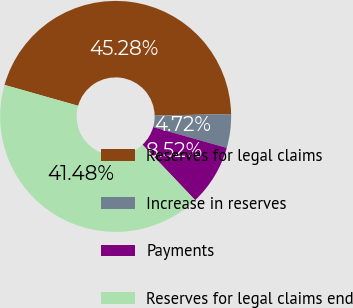Convert chart to OTSL. <chart><loc_0><loc_0><loc_500><loc_500><pie_chart><fcel>Reserves for legal claims<fcel>Increase in reserves<fcel>Payments<fcel>Reserves for legal claims end<nl><fcel>45.28%<fcel>4.72%<fcel>8.52%<fcel>41.48%<nl></chart> 